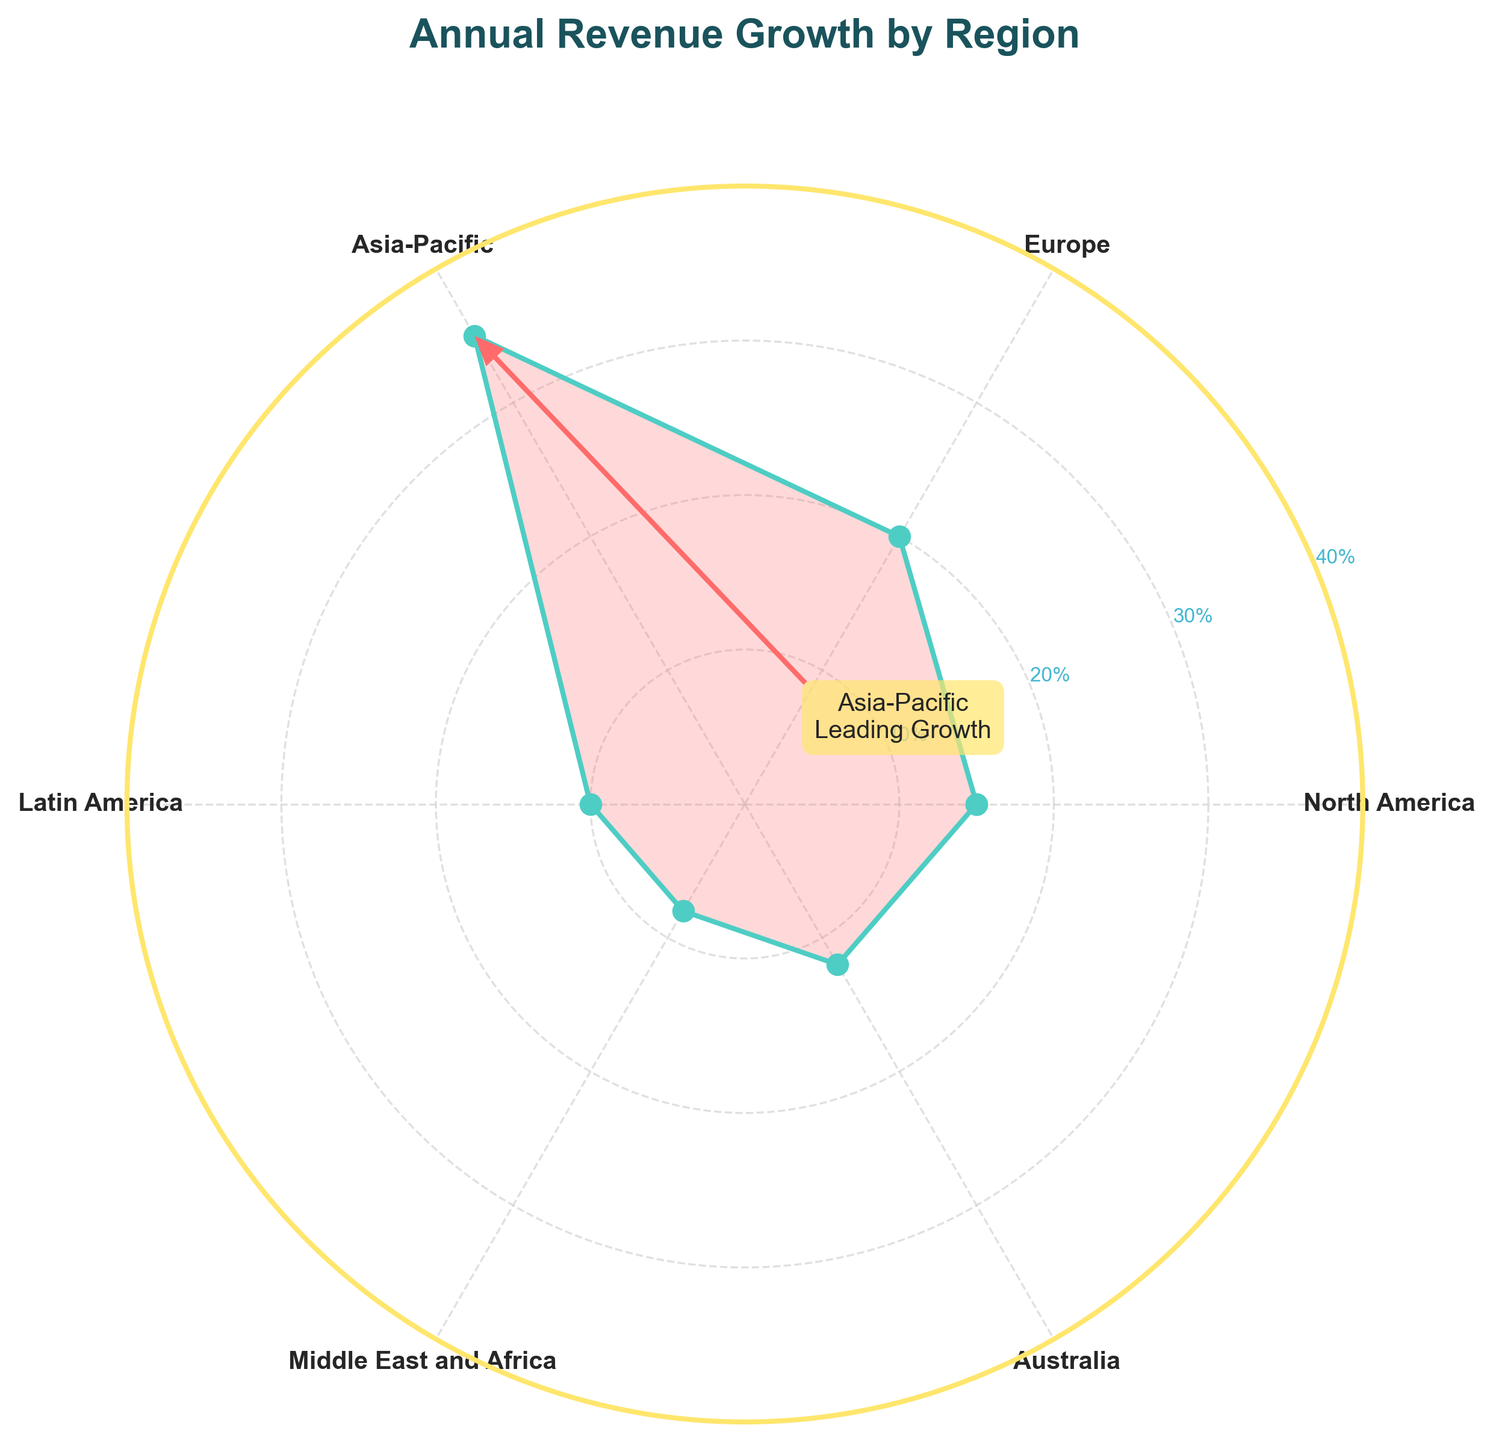What is the title of the chart? The title of the chart is usually found at the top of the figure. In this chart, it is clearly labeled above the plot area.
Answer: "Annual Revenue Growth by Region" Which region has the highest annual revenue growth percentage? The region with the highest annual revenue growth percentage can be identified by locating the segment that extends furthest from the center of the polar area chart. In this chart, the Asia-Pacific region shows the highest value.
Answer: Asia-Pacific How many data points are displayed in this chart? The number of data points corresponds to the number of distinct regions displayed around the polar chart. Each region is marked with an angle on the circular plot. Counting these, we have six distinct regions.
Answer: 6 What is the annual revenue growth percentage for Europe? The annual revenue growth percentage for Europe can be found by identifying the angle labeled 'Europe' and checking the corresponding value. Europe is labeled at one of the angles, and the value given is 20%.
Answer: 20% Which region has the lowest annual revenue growth percentage? To find the region with the lowest growth percentage, identify the segment that is closest to the center of the polar chart. The Middle East and Africa region extends least from the center, indicating the lowest percentage.
Answer: Middle East and Africa What is the difference in annual revenue growth percentage between the region with the highest growth and the region with the lowest growth? The region with the highest growth is Asia-Pacific with 35%, and the region with the lowest growth is Middle East and Africa with 8%. The difference is calculated as 35% - 8%.
Answer: 27% Compare the annual revenue growth percentage of Australia and Latin America. Which one is higher and by how much? Australia has an annual revenue growth percentage of 12%, and Latin America has 10%. The difference is calculated as 12% - 10%. Australia has a higher percentage by this difference.
Answer: 2% Which two regions have an annual revenue growth percentage closest to each other? Looking at the polar chart, we observe the lengths of each segment. North America with 15% and Australia with 12% have the closest values as their segments appear quite similar in length. The difference between them is the smallest.
Answer: North America and Australia What is the average annual revenue growth percentage across all regions? To find the average, add the annual revenue growth percentages of all regions: 15% (North America) + 20% (Europe) + 35% (Asia-Pacific) + 10% (Latin America) + 8% (Middle East and Africa) + 12% (Australia) = 100%. Then divide by the number of regions (6). 100% / 6 = 16.67%.
Answer: 16.67% In the polar chart, how is the leading region in growth visually highlighted? The leading region, Asia-Pacific, is represented with its segment extending furthest from the center. Additionally, it is specifically annotated with a label and an arrow, making it stand out visually.
Answer: Annotated with label and arrow 